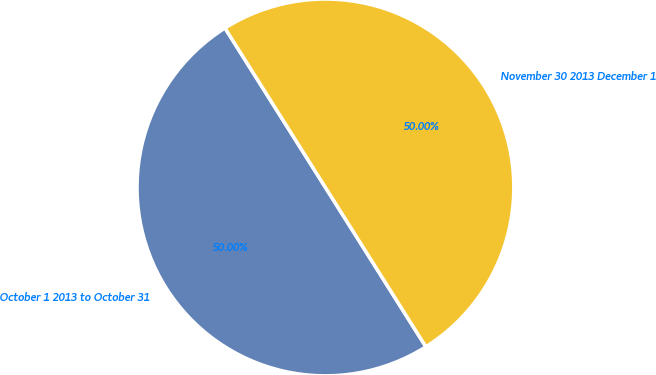Convert chart. <chart><loc_0><loc_0><loc_500><loc_500><pie_chart><fcel>October 1 2013 to October 31<fcel>November 30 2013 December 1<nl><fcel>50.0%<fcel>50.0%<nl></chart> 